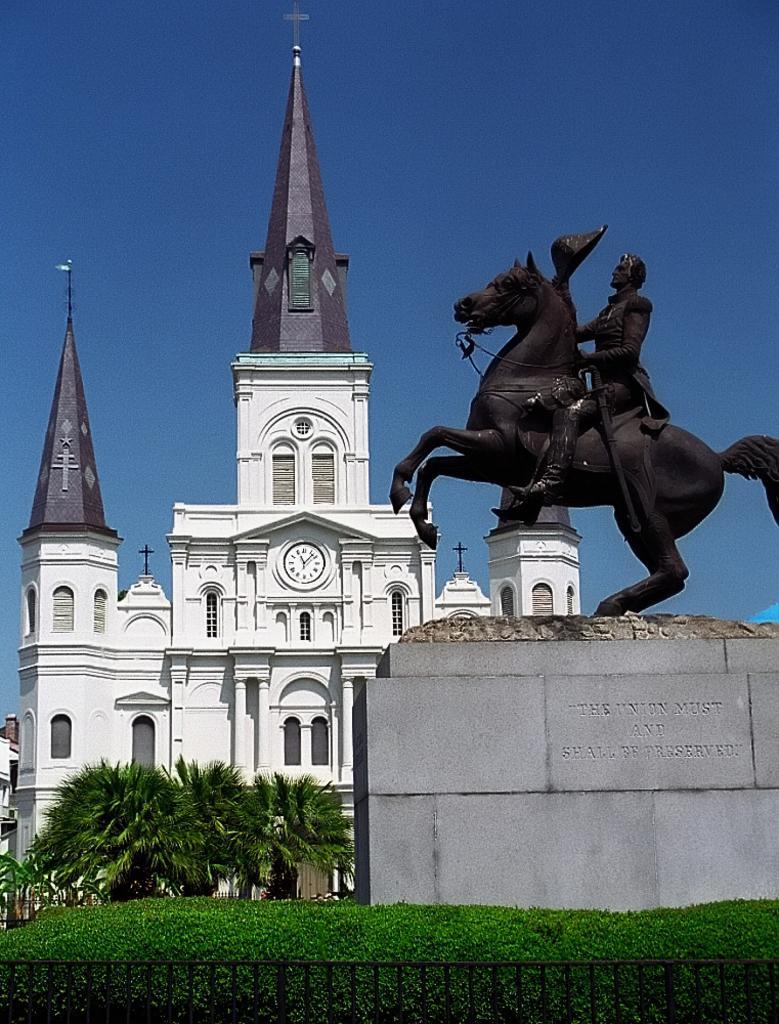Could you give a brief overview of what you see in this image? In the picture i can see a statue which is of a person sitting on horse, there is grass, there are trees and in the background of the image there is building, there is clear sky. 